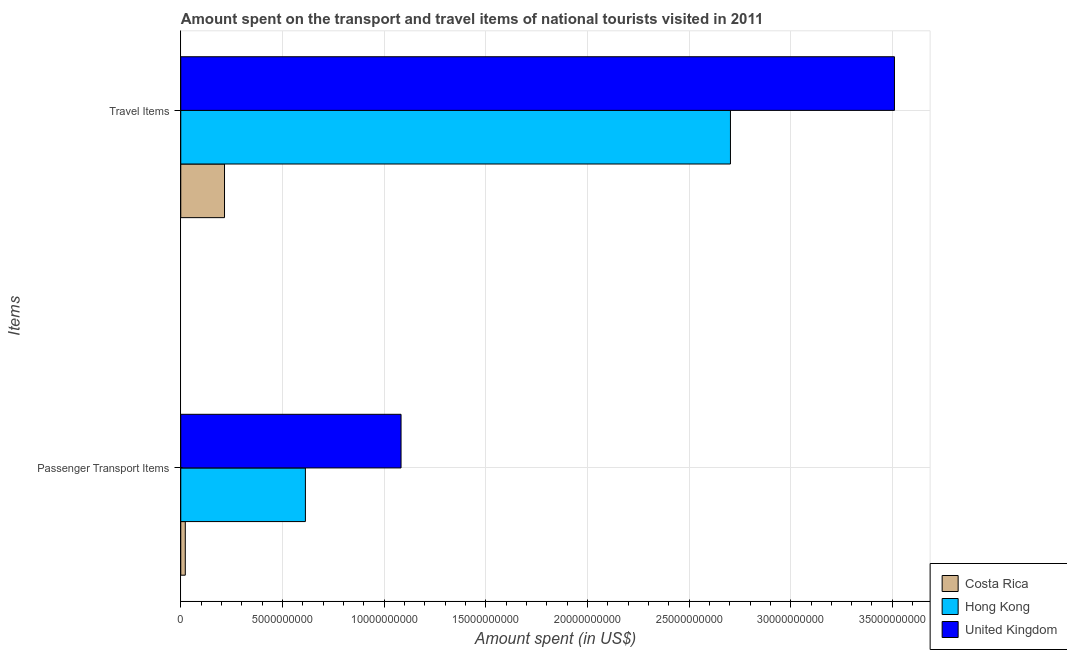How many different coloured bars are there?
Make the answer very short. 3. How many groups of bars are there?
Offer a terse response. 2. Are the number of bars on each tick of the Y-axis equal?
Your answer should be very brief. Yes. How many bars are there on the 1st tick from the top?
Your answer should be compact. 3. What is the label of the 1st group of bars from the top?
Provide a short and direct response. Travel Items. What is the amount spent on passenger transport items in Costa Rica?
Your answer should be very brief. 2.23e+08. Across all countries, what is the maximum amount spent in travel items?
Ensure brevity in your answer.  3.51e+1. Across all countries, what is the minimum amount spent on passenger transport items?
Offer a terse response. 2.23e+08. In which country was the amount spent in travel items minimum?
Make the answer very short. Costa Rica. What is the total amount spent on passenger transport items in the graph?
Your answer should be compact. 1.72e+1. What is the difference between the amount spent on passenger transport items in United Kingdom and that in Hong Kong?
Provide a succinct answer. 4.70e+09. What is the difference between the amount spent on passenger transport items in United Kingdom and the amount spent in travel items in Costa Rica?
Your answer should be very brief. 8.68e+09. What is the average amount spent on passenger transport items per country?
Keep it short and to the point. 5.73e+09. What is the difference between the amount spent in travel items and amount spent on passenger transport items in United Kingdom?
Offer a terse response. 2.43e+1. In how many countries, is the amount spent in travel items greater than 28000000000 US$?
Offer a very short reply. 1. What is the ratio of the amount spent in travel items in Costa Rica to that in United Kingdom?
Your response must be concise. 0.06. Is the amount spent on passenger transport items in United Kingdom less than that in Costa Rica?
Provide a short and direct response. No. What does the 2nd bar from the top in Travel Items represents?
Your answer should be very brief. Hong Kong. What does the 2nd bar from the bottom in Travel Items represents?
Offer a terse response. Hong Kong. How many bars are there?
Offer a terse response. 6. How many countries are there in the graph?
Your answer should be compact. 3. What is the difference between two consecutive major ticks on the X-axis?
Provide a short and direct response. 5.00e+09. Are the values on the major ticks of X-axis written in scientific E-notation?
Your response must be concise. No. Does the graph contain any zero values?
Give a very brief answer. No. How many legend labels are there?
Your answer should be very brief. 3. What is the title of the graph?
Make the answer very short. Amount spent on the transport and travel items of national tourists visited in 2011. Does "Cuba" appear as one of the legend labels in the graph?
Offer a terse response. No. What is the label or title of the X-axis?
Make the answer very short. Amount spent (in US$). What is the label or title of the Y-axis?
Offer a terse response. Items. What is the Amount spent (in US$) of Costa Rica in Passenger Transport Items?
Your response must be concise. 2.23e+08. What is the Amount spent (in US$) of Hong Kong in Passenger Transport Items?
Make the answer very short. 6.13e+09. What is the Amount spent (in US$) of United Kingdom in Passenger Transport Items?
Offer a terse response. 1.08e+1. What is the Amount spent (in US$) in Costa Rica in Travel Items?
Offer a very short reply. 2.15e+09. What is the Amount spent (in US$) of Hong Kong in Travel Items?
Make the answer very short. 2.70e+1. What is the Amount spent (in US$) of United Kingdom in Travel Items?
Ensure brevity in your answer.  3.51e+1. Across all Items, what is the maximum Amount spent (in US$) of Costa Rica?
Your answer should be compact. 2.15e+09. Across all Items, what is the maximum Amount spent (in US$) of Hong Kong?
Your answer should be compact. 2.70e+1. Across all Items, what is the maximum Amount spent (in US$) in United Kingdom?
Provide a short and direct response. 3.51e+1. Across all Items, what is the minimum Amount spent (in US$) in Costa Rica?
Keep it short and to the point. 2.23e+08. Across all Items, what is the minimum Amount spent (in US$) in Hong Kong?
Provide a succinct answer. 6.13e+09. Across all Items, what is the minimum Amount spent (in US$) of United Kingdom?
Your answer should be compact. 1.08e+1. What is the total Amount spent (in US$) in Costa Rica in the graph?
Provide a succinct answer. 2.38e+09. What is the total Amount spent (in US$) in Hong Kong in the graph?
Provide a succinct answer. 3.32e+1. What is the total Amount spent (in US$) in United Kingdom in the graph?
Your response must be concise. 4.59e+1. What is the difference between the Amount spent (in US$) of Costa Rica in Passenger Transport Items and that in Travel Items?
Keep it short and to the point. -1.93e+09. What is the difference between the Amount spent (in US$) of Hong Kong in Passenger Transport Items and that in Travel Items?
Ensure brevity in your answer.  -2.09e+1. What is the difference between the Amount spent (in US$) of United Kingdom in Passenger Transport Items and that in Travel Items?
Offer a very short reply. -2.43e+1. What is the difference between the Amount spent (in US$) in Costa Rica in Passenger Transport Items and the Amount spent (in US$) in Hong Kong in Travel Items?
Make the answer very short. -2.68e+1. What is the difference between the Amount spent (in US$) in Costa Rica in Passenger Transport Items and the Amount spent (in US$) in United Kingdom in Travel Items?
Ensure brevity in your answer.  -3.49e+1. What is the difference between the Amount spent (in US$) of Hong Kong in Passenger Transport Items and the Amount spent (in US$) of United Kingdom in Travel Items?
Keep it short and to the point. -2.90e+1. What is the average Amount spent (in US$) of Costa Rica per Items?
Offer a very short reply. 1.19e+09. What is the average Amount spent (in US$) in Hong Kong per Items?
Your response must be concise. 1.66e+1. What is the average Amount spent (in US$) in United Kingdom per Items?
Make the answer very short. 2.30e+1. What is the difference between the Amount spent (in US$) in Costa Rica and Amount spent (in US$) in Hong Kong in Passenger Transport Items?
Provide a succinct answer. -5.91e+09. What is the difference between the Amount spent (in US$) of Costa Rica and Amount spent (in US$) of United Kingdom in Passenger Transport Items?
Your answer should be compact. -1.06e+1. What is the difference between the Amount spent (in US$) of Hong Kong and Amount spent (in US$) of United Kingdom in Passenger Transport Items?
Your response must be concise. -4.70e+09. What is the difference between the Amount spent (in US$) of Costa Rica and Amount spent (in US$) of Hong Kong in Travel Items?
Keep it short and to the point. -2.49e+1. What is the difference between the Amount spent (in US$) in Costa Rica and Amount spent (in US$) in United Kingdom in Travel Items?
Provide a short and direct response. -3.30e+1. What is the difference between the Amount spent (in US$) in Hong Kong and Amount spent (in US$) in United Kingdom in Travel Items?
Your response must be concise. -8.07e+09. What is the ratio of the Amount spent (in US$) in Costa Rica in Passenger Transport Items to that in Travel Items?
Provide a succinct answer. 0.1. What is the ratio of the Amount spent (in US$) in Hong Kong in Passenger Transport Items to that in Travel Items?
Make the answer very short. 0.23. What is the ratio of the Amount spent (in US$) in United Kingdom in Passenger Transport Items to that in Travel Items?
Keep it short and to the point. 0.31. What is the difference between the highest and the second highest Amount spent (in US$) of Costa Rica?
Your answer should be compact. 1.93e+09. What is the difference between the highest and the second highest Amount spent (in US$) in Hong Kong?
Provide a succinct answer. 2.09e+1. What is the difference between the highest and the second highest Amount spent (in US$) in United Kingdom?
Offer a very short reply. 2.43e+1. What is the difference between the highest and the lowest Amount spent (in US$) in Costa Rica?
Make the answer very short. 1.93e+09. What is the difference between the highest and the lowest Amount spent (in US$) of Hong Kong?
Make the answer very short. 2.09e+1. What is the difference between the highest and the lowest Amount spent (in US$) of United Kingdom?
Give a very brief answer. 2.43e+1. 